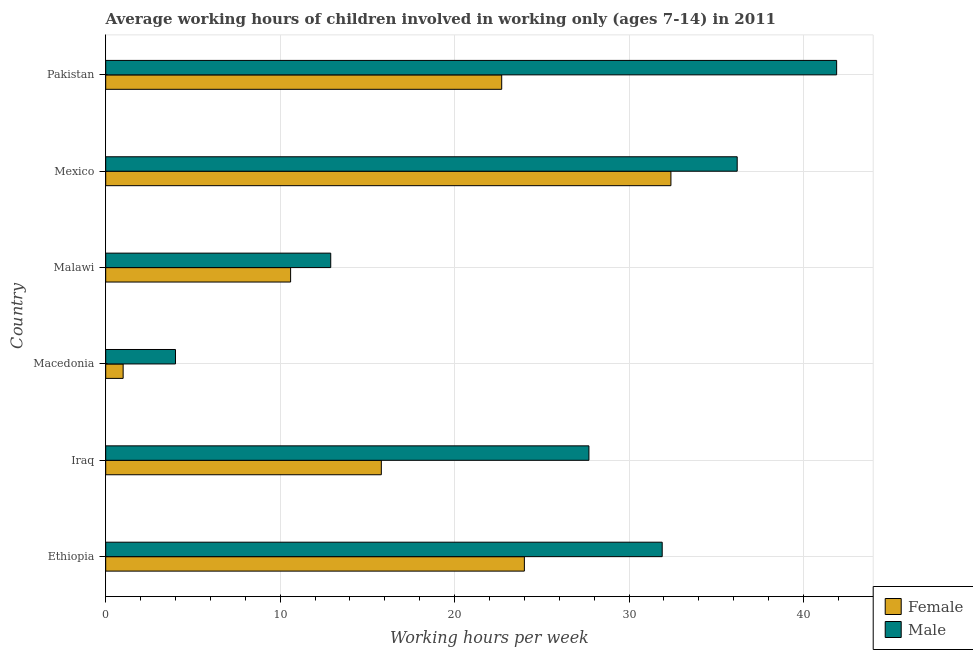How many different coloured bars are there?
Provide a succinct answer. 2. How many groups of bars are there?
Offer a very short reply. 6. Are the number of bars on each tick of the Y-axis equal?
Offer a very short reply. Yes. How many bars are there on the 3rd tick from the top?
Provide a succinct answer. 2. What is the label of the 4th group of bars from the top?
Give a very brief answer. Macedonia. In how many cases, is the number of bars for a given country not equal to the number of legend labels?
Ensure brevity in your answer.  0. Across all countries, what is the maximum average working hour of female children?
Your answer should be very brief. 32.4. Across all countries, what is the minimum average working hour of female children?
Keep it short and to the point. 1. In which country was the average working hour of male children maximum?
Provide a short and direct response. Pakistan. In which country was the average working hour of female children minimum?
Offer a very short reply. Macedonia. What is the total average working hour of male children in the graph?
Keep it short and to the point. 154.6. What is the difference between the average working hour of male children in Ethiopia and the average working hour of female children in Iraq?
Keep it short and to the point. 16.1. What is the average average working hour of female children per country?
Your response must be concise. 17.75. In how many countries, is the average working hour of female children greater than 18 hours?
Provide a succinct answer. 3. What is the ratio of the average working hour of male children in Macedonia to that in Malawi?
Make the answer very short. 0.31. Is the average working hour of male children in Mexico less than that in Pakistan?
Offer a very short reply. Yes. Is the difference between the average working hour of male children in Ethiopia and Iraq greater than the difference between the average working hour of female children in Ethiopia and Iraq?
Offer a terse response. No. What is the difference between the highest and the lowest average working hour of male children?
Provide a succinct answer. 37.9. What does the 1st bar from the top in Mexico represents?
Provide a short and direct response. Male. What does the 2nd bar from the bottom in Malawi represents?
Ensure brevity in your answer.  Male. Are all the bars in the graph horizontal?
Provide a succinct answer. Yes. Are the values on the major ticks of X-axis written in scientific E-notation?
Your response must be concise. No. How are the legend labels stacked?
Provide a short and direct response. Vertical. What is the title of the graph?
Ensure brevity in your answer.  Average working hours of children involved in working only (ages 7-14) in 2011. Does "By country of origin" appear as one of the legend labels in the graph?
Your answer should be compact. No. What is the label or title of the X-axis?
Provide a succinct answer. Working hours per week. What is the Working hours per week of Male in Ethiopia?
Your answer should be compact. 31.9. What is the Working hours per week of Male in Iraq?
Make the answer very short. 27.7. What is the Working hours per week in Male in Macedonia?
Offer a terse response. 4. What is the Working hours per week of Female in Malawi?
Provide a succinct answer. 10.6. What is the Working hours per week in Male in Malawi?
Make the answer very short. 12.9. What is the Working hours per week in Female in Mexico?
Offer a terse response. 32.4. What is the Working hours per week of Male in Mexico?
Provide a short and direct response. 36.2. What is the Working hours per week in Female in Pakistan?
Ensure brevity in your answer.  22.7. What is the Working hours per week of Male in Pakistan?
Your answer should be very brief. 41.9. Across all countries, what is the maximum Working hours per week in Female?
Offer a terse response. 32.4. Across all countries, what is the maximum Working hours per week of Male?
Offer a terse response. 41.9. Across all countries, what is the minimum Working hours per week of Female?
Keep it short and to the point. 1. Across all countries, what is the minimum Working hours per week in Male?
Give a very brief answer. 4. What is the total Working hours per week in Female in the graph?
Provide a succinct answer. 106.5. What is the total Working hours per week in Male in the graph?
Your response must be concise. 154.6. What is the difference between the Working hours per week in Male in Ethiopia and that in Iraq?
Provide a short and direct response. 4.2. What is the difference between the Working hours per week of Female in Ethiopia and that in Macedonia?
Ensure brevity in your answer.  23. What is the difference between the Working hours per week in Male in Ethiopia and that in Macedonia?
Provide a short and direct response. 27.9. What is the difference between the Working hours per week in Male in Ethiopia and that in Malawi?
Your answer should be very brief. 19. What is the difference between the Working hours per week of Male in Ethiopia and that in Mexico?
Give a very brief answer. -4.3. What is the difference between the Working hours per week in Female in Ethiopia and that in Pakistan?
Your response must be concise. 1.3. What is the difference between the Working hours per week of Female in Iraq and that in Macedonia?
Offer a terse response. 14.8. What is the difference between the Working hours per week in Male in Iraq and that in Macedonia?
Make the answer very short. 23.7. What is the difference between the Working hours per week in Female in Iraq and that in Malawi?
Your answer should be very brief. 5.2. What is the difference between the Working hours per week in Male in Iraq and that in Malawi?
Your answer should be very brief. 14.8. What is the difference between the Working hours per week of Female in Iraq and that in Mexico?
Your answer should be compact. -16.6. What is the difference between the Working hours per week in Female in Macedonia and that in Malawi?
Provide a succinct answer. -9.6. What is the difference between the Working hours per week of Female in Macedonia and that in Mexico?
Keep it short and to the point. -31.4. What is the difference between the Working hours per week in Male in Macedonia and that in Mexico?
Provide a succinct answer. -32.2. What is the difference between the Working hours per week in Female in Macedonia and that in Pakistan?
Provide a short and direct response. -21.7. What is the difference between the Working hours per week of Male in Macedonia and that in Pakistan?
Ensure brevity in your answer.  -37.9. What is the difference between the Working hours per week in Female in Malawi and that in Mexico?
Offer a very short reply. -21.8. What is the difference between the Working hours per week in Male in Malawi and that in Mexico?
Ensure brevity in your answer.  -23.3. What is the difference between the Working hours per week of Female in Mexico and that in Pakistan?
Your answer should be very brief. 9.7. What is the difference between the Working hours per week of Male in Mexico and that in Pakistan?
Your answer should be very brief. -5.7. What is the difference between the Working hours per week of Female in Ethiopia and the Working hours per week of Male in Iraq?
Your answer should be very brief. -3.7. What is the difference between the Working hours per week in Female in Ethiopia and the Working hours per week in Male in Pakistan?
Your answer should be very brief. -17.9. What is the difference between the Working hours per week of Female in Iraq and the Working hours per week of Male in Malawi?
Make the answer very short. 2.9. What is the difference between the Working hours per week of Female in Iraq and the Working hours per week of Male in Mexico?
Your answer should be compact. -20.4. What is the difference between the Working hours per week of Female in Iraq and the Working hours per week of Male in Pakistan?
Keep it short and to the point. -26.1. What is the difference between the Working hours per week in Female in Macedonia and the Working hours per week in Male in Mexico?
Ensure brevity in your answer.  -35.2. What is the difference between the Working hours per week in Female in Macedonia and the Working hours per week in Male in Pakistan?
Your response must be concise. -40.9. What is the difference between the Working hours per week in Female in Malawi and the Working hours per week in Male in Mexico?
Ensure brevity in your answer.  -25.6. What is the difference between the Working hours per week in Female in Malawi and the Working hours per week in Male in Pakistan?
Offer a terse response. -31.3. What is the average Working hours per week of Female per country?
Your answer should be very brief. 17.75. What is the average Working hours per week of Male per country?
Give a very brief answer. 25.77. What is the difference between the Working hours per week in Female and Working hours per week in Male in Iraq?
Offer a very short reply. -11.9. What is the difference between the Working hours per week of Female and Working hours per week of Male in Malawi?
Provide a succinct answer. -2.3. What is the difference between the Working hours per week of Female and Working hours per week of Male in Mexico?
Provide a succinct answer. -3.8. What is the difference between the Working hours per week of Female and Working hours per week of Male in Pakistan?
Your answer should be compact. -19.2. What is the ratio of the Working hours per week in Female in Ethiopia to that in Iraq?
Make the answer very short. 1.52. What is the ratio of the Working hours per week of Male in Ethiopia to that in Iraq?
Your answer should be compact. 1.15. What is the ratio of the Working hours per week of Female in Ethiopia to that in Macedonia?
Ensure brevity in your answer.  24. What is the ratio of the Working hours per week in Male in Ethiopia to that in Macedonia?
Provide a short and direct response. 7.97. What is the ratio of the Working hours per week of Female in Ethiopia to that in Malawi?
Your answer should be compact. 2.26. What is the ratio of the Working hours per week of Male in Ethiopia to that in Malawi?
Keep it short and to the point. 2.47. What is the ratio of the Working hours per week in Female in Ethiopia to that in Mexico?
Offer a very short reply. 0.74. What is the ratio of the Working hours per week of Male in Ethiopia to that in Mexico?
Provide a short and direct response. 0.88. What is the ratio of the Working hours per week in Female in Ethiopia to that in Pakistan?
Offer a terse response. 1.06. What is the ratio of the Working hours per week of Male in Ethiopia to that in Pakistan?
Your answer should be very brief. 0.76. What is the ratio of the Working hours per week in Male in Iraq to that in Macedonia?
Keep it short and to the point. 6.92. What is the ratio of the Working hours per week in Female in Iraq to that in Malawi?
Make the answer very short. 1.49. What is the ratio of the Working hours per week in Male in Iraq to that in Malawi?
Provide a short and direct response. 2.15. What is the ratio of the Working hours per week of Female in Iraq to that in Mexico?
Provide a short and direct response. 0.49. What is the ratio of the Working hours per week of Male in Iraq to that in Mexico?
Your answer should be very brief. 0.77. What is the ratio of the Working hours per week in Female in Iraq to that in Pakistan?
Keep it short and to the point. 0.7. What is the ratio of the Working hours per week in Male in Iraq to that in Pakistan?
Your answer should be compact. 0.66. What is the ratio of the Working hours per week in Female in Macedonia to that in Malawi?
Make the answer very short. 0.09. What is the ratio of the Working hours per week of Male in Macedonia to that in Malawi?
Provide a succinct answer. 0.31. What is the ratio of the Working hours per week of Female in Macedonia to that in Mexico?
Your answer should be very brief. 0.03. What is the ratio of the Working hours per week in Male in Macedonia to that in Mexico?
Your response must be concise. 0.11. What is the ratio of the Working hours per week in Female in Macedonia to that in Pakistan?
Keep it short and to the point. 0.04. What is the ratio of the Working hours per week in Male in Macedonia to that in Pakistan?
Your answer should be very brief. 0.1. What is the ratio of the Working hours per week in Female in Malawi to that in Mexico?
Provide a short and direct response. 0.33. What is the ratio of the Working hours per week of Male in Malawi to that in Mexico?
Offer a terse response. 0.36. What is the ratio of the Working hours per week in Female in Malawi to that in Pakistan?
Offer a very short reply. 0.47. What is the ratio of the Working hours per week in Male in Malawi to that in Pakistan?
Give a very brief answer. 0.31. What is the ratio of the Working hours per week of Female in Mexico to that in Pakistan?
Make the answer very short. 1.43. What is the ratio of the Working hours per week of Male in Mexico to that in Pakistan?
Your response must be concise. 0.86. What is the difference between the highest and the second highest Working hours per week in Male?
Your answer should be very brief. 5.7. What is the difference between the highest and the lowest Working hours per week of Female?
Your answer should be very brief. 31.4. What is the difference between the highest and the lowest Working hours per week in Male?
Give a very brief answer. 37.9. 